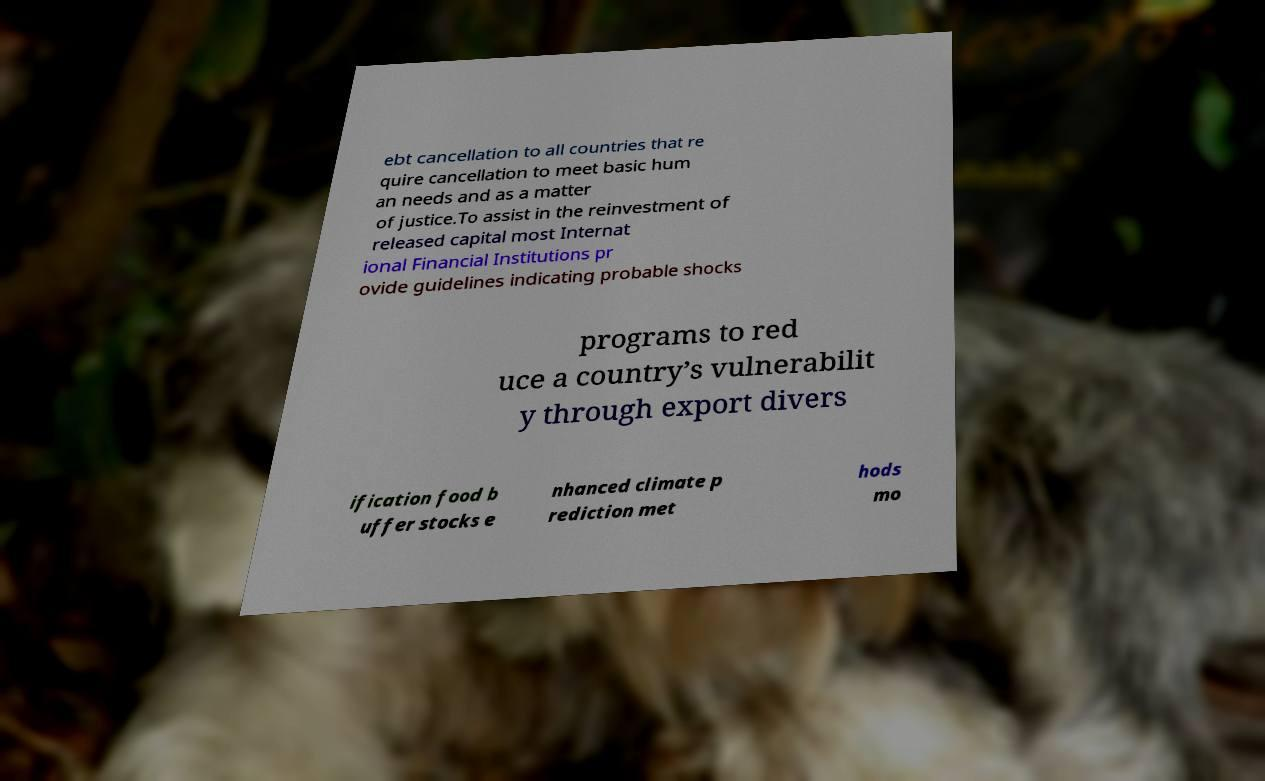Can you accurately transcribe the text from the provided image for me? ebt cancellation to all countries that re quire cancellation to meet basic hum an needs and as a matter of justice.To assist in the reinvestment of released capital most Internat ional Financial Institutions pr ovide guidelines indicating probable shocks programs to red uce a country’s vulnerabilit y through export divers ification food b uffer stocks e nhanced climate p rediction met hods mo 